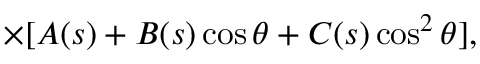Convert formula to latex. <formula><loc_0><loc_0><loc_500><loc_500>\times [ A ( s ) + B ( s ) \cos \theta + C ( s ) \cos ^ { 2 } \theta ] ,</formula> 